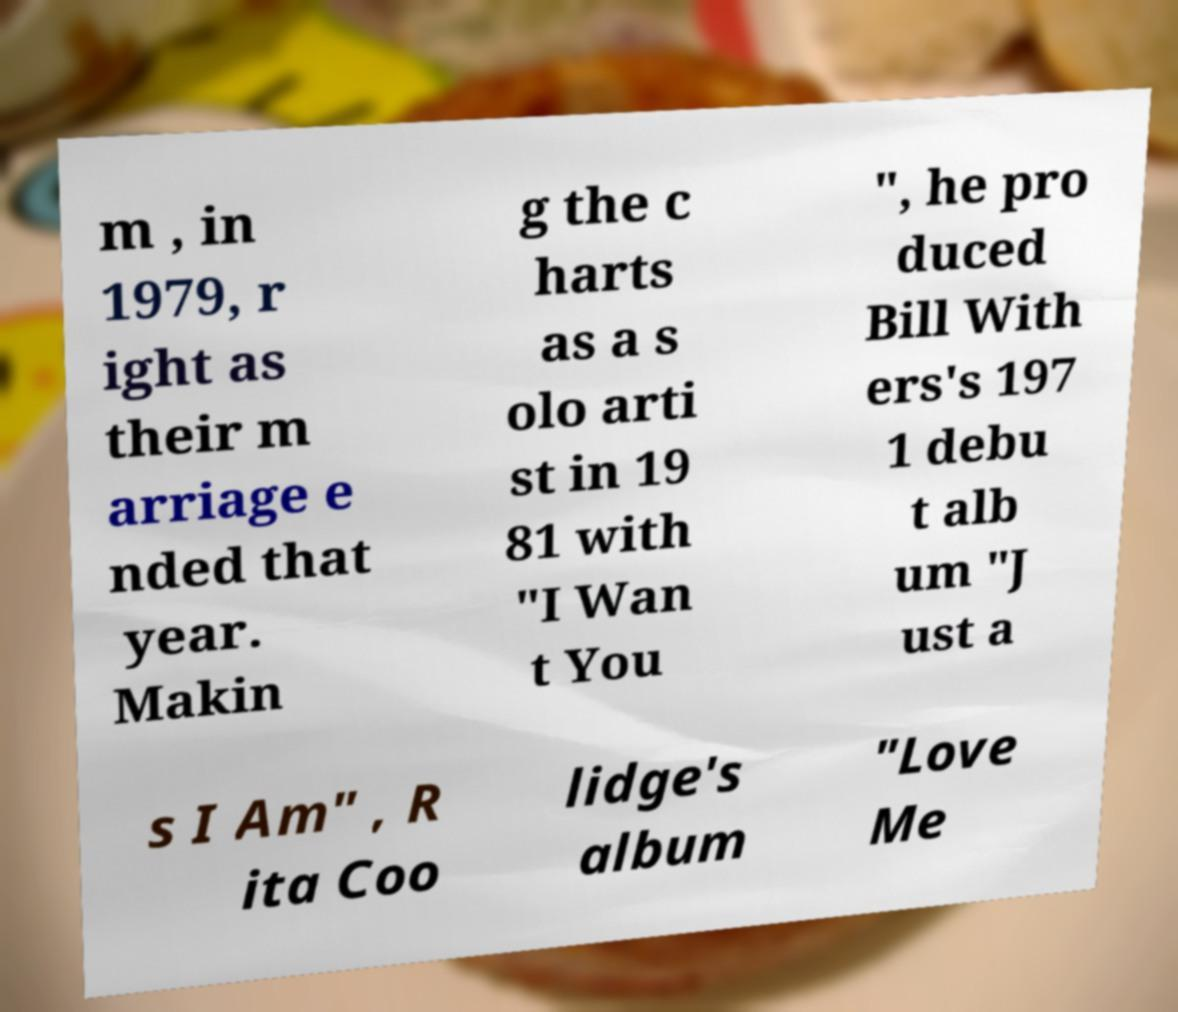Can you accurately transcribe the text from the provided image for me? m , in 1979, r ight as their m arriage e nded that year. Makin g the c harts as a s olo arti st in 19 81 with "I Wan t You ", he pro duced Bill With ers's 197 1 debu t alb um "J ust a s I Am" , R ita Coo lidge's album "Love Me 